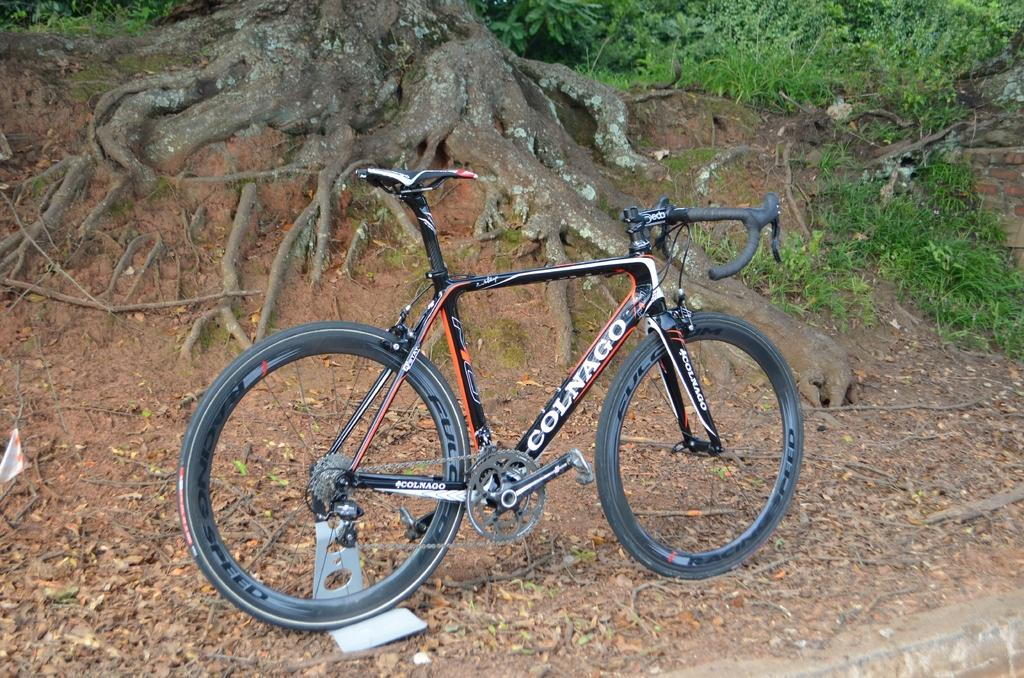What is the main object in the picture? There is a bicycle in the picture. What else can be seen in the picture besides the bicycle? There are plants and grass in the picture. Can you describe the background of the picture? The background of the picture includes roots of a tree. What type of can is visible in the picture? There is no can present in the picture; it features a bicycle, plants, grass, and tree roots. What arithmetic problem can be solved using the plants in the picture? The plants in the picture are not related to arithmetic problems, as they are part of the natural environment depicted in the image. 